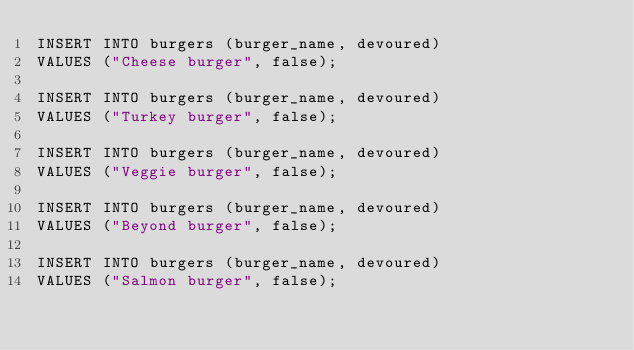Convert code to text. <code><loc_0><loc_0><loc_500><loc_500><_SQL_>INSERT INTO burgers (burger_name, devoured)
VALUES ("Cheese burger", false);

INSERT INTO burgers (burger_name, devoured)
VALUES ("Turkey burger", false);

INSERT INTO burgers (burger_name, devoured)
VALUES ("Veggie burger", false);

INSERT INTO burgers (burger_name, devoured)
VALUES ("Beyond burger", false);

INSERT INTO burgers (burger_name, devoured)
VALUES ("Salmon burger", false);</code> 